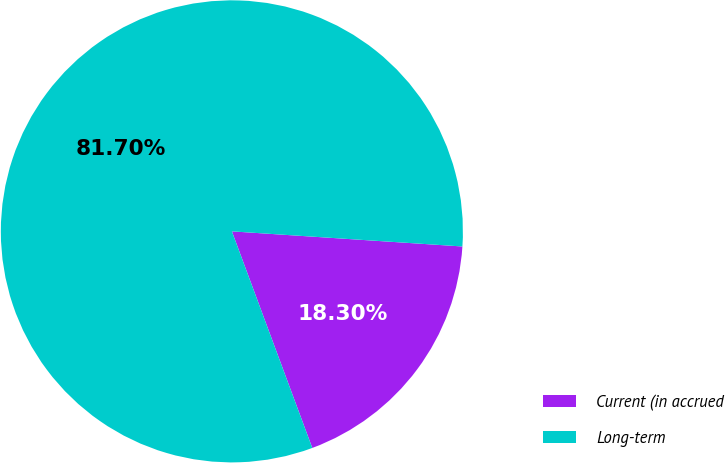Convert chart. <chart><loc_0><loc_0><loc_500><loc_500><pie_chart><fcel>Current (in accrued<fcel>Long-term<nl><fcel>18.3%<fcel>81.7%<nl></chart> 